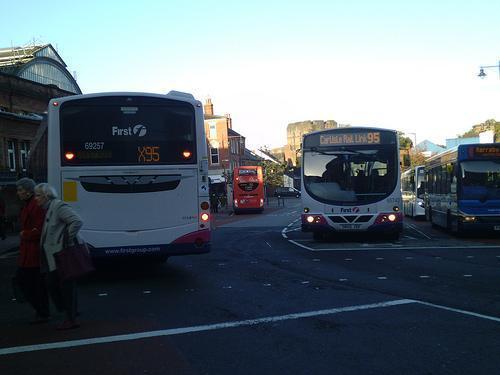How many people are pictured?
Give a very brief answer. 2. 